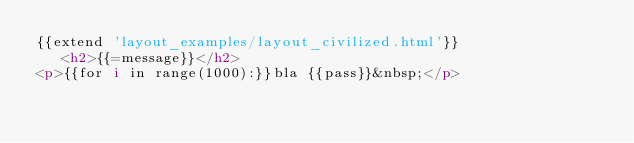Convert code to text. <code><loc_0><loc_0><loc_500><loc_500><_HTML_>{{extend 'layout_examples/layout_civilized.html'}}
   <h2>{{=message}}</h2>
<p>{{for i in range(1000):}}bla {{pass}}&nbsp;</p>
</code> 